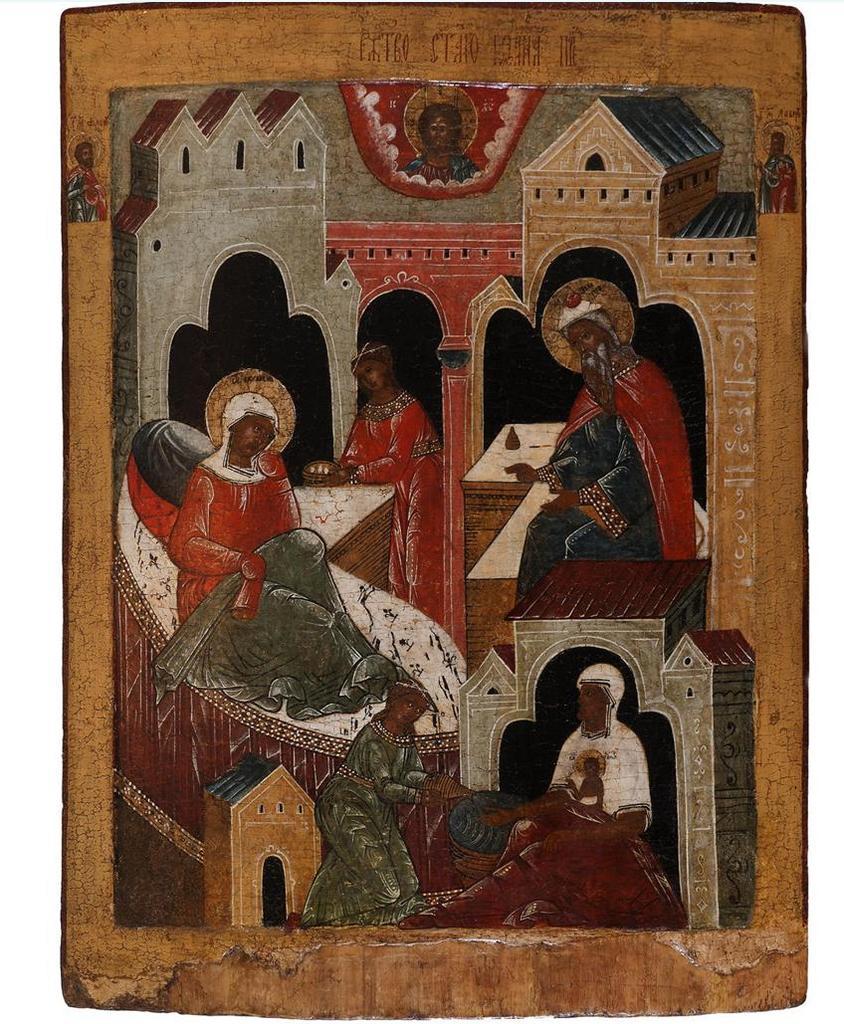How would you summarize this image in a sentence or two? In the image we can see the painting on the wall. In the painting we can see there are people wearing clothes and we can see the building. 